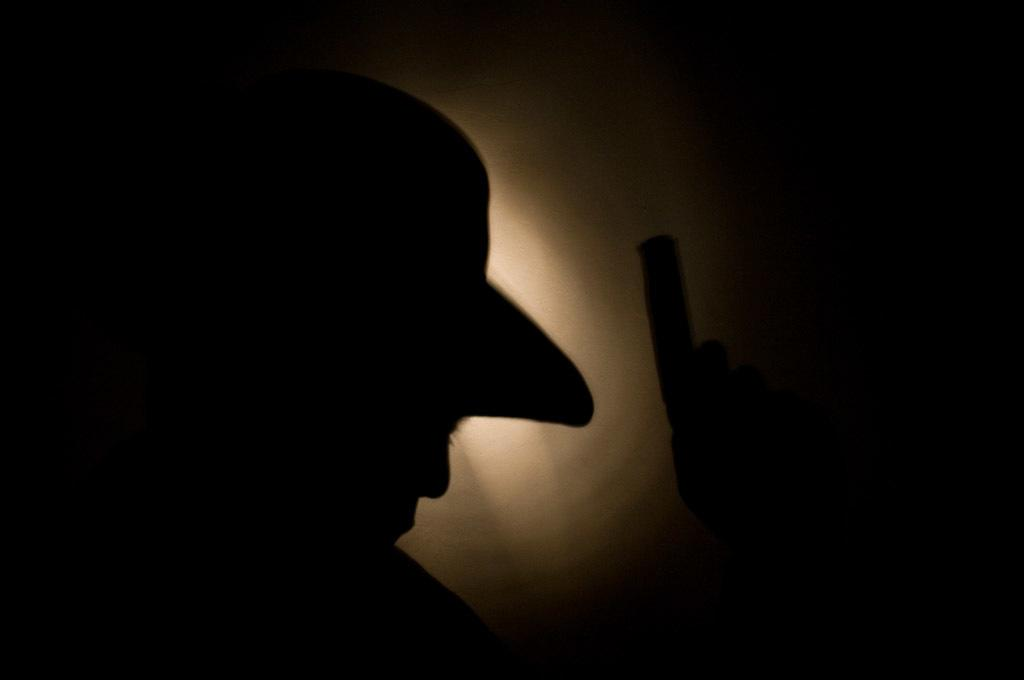What is the overall appearance of the image? The image is completely in dark. What type of ice can be seen melting in the image? There is no ice present in the image, as it is completely in dark. What kind of paste is being used to write a verse in the image? There is no paste or writing visible in the image, as it is completely in dark. 